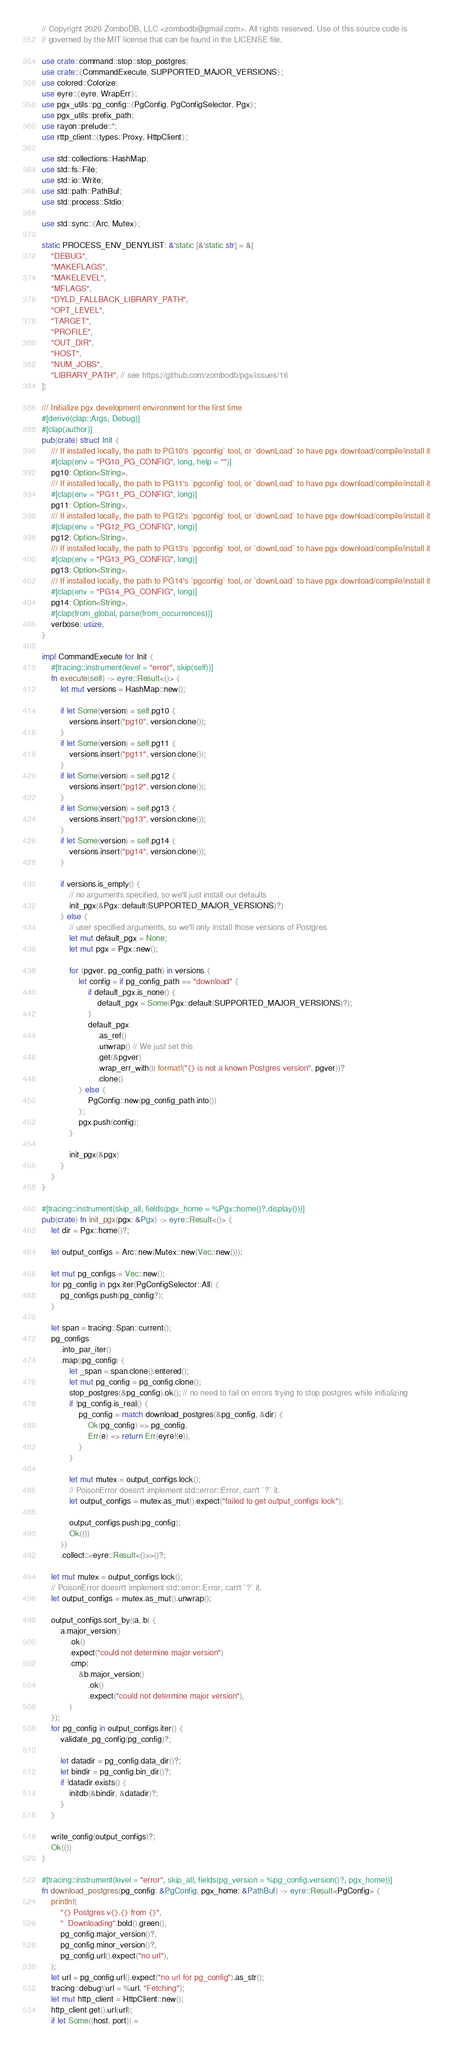Convert code to text. <code><loc_0><loc_0><loc_500><loc_500><_Rust_>// Copyright 2020 ZomboDB, LLC <zombodb@gmail.com>. All rights reserved. Use of this source code is
// governed by the MIT license that can be found in the LICENSE file.

use crate::command::stop::stop_postgres;
use crate::{CommandExecute, SUPPORTED_MAJOR_VERSIONS};
use colored::Colorize;
use eyre::{eyre, WrapErr};
use pgx_utils::pg_config::{PgConfig, PgConfigSelector, Pgx};
use pgx_utils::prefix_path;
use rayon::prelude::*;
use rttp_client::{types::Proxy, HttpClient};

use std::collections::HashMap;
use std::fs::File;
use std::io::Write;
use std::path::PathBuf;
use std::process::Stdio;

use std::sync::{Arc, Mutex};

static PROCESS_ENV_DENYLIST: &'static [&'static str] = &[
    "DEBUG",
    "MAKEFLAGS",
    "MAKELEVEL",
    "MFLAGS",
    "DYLD_FALLBACK_LIBRARY_PATH",
    "OPT_LEVEL",
    "TARGET",
    "PROFILE",
    "OUT_DIR",
    "HOST",
    "NUM_JOBS",
    "LIBRARY_PATH", // see https://github.com/zombodb/pgx/issues/16
];

/// Initialize pgx development environment for the first time
#[derive(clap::Args, Debug)]
#[clap(author)]
pub(crate) struct Init {
    /// If installed locally, the path to PG10's `pgconfig` tool, or `downLoad` to have pgx download/compile/install it
    #[clap(env = "PG10_PG_CONFIG", long, help = "")]
    pg10: Option<String>,
    /// If installed locally, the path to PG11's `pgconfig` tool, or `downLoad` to have pgx download/compile/install it
    #[clap(env = "PG11_PG_CONFIG", long)]
    pg11: Option<String>,
    /// If installed locally, the path to PG12's `pgconfig` tool, or `downLoad` to have pgx download/compile/install it
    #[clap(env = "PG12_PG_CONFIG", long)]
    pg12: Option<String>,
    /// If installed locally, the path to PG13's `pgconfig` tool, or `downLoad` to have pgx download/compile/install it
    #[clap(env = "PG13_PG_CONFIG", long)]
    pg13: Option<String>,
    /// If installed locally, the path to PG14's `pgconfig` tool, or `downLoad` to have pgx download/compile/install it
    #[clap(env = "PG14_PG_CONFIG", long)]
    pg14: Option<String>,
    #[clap(from_global, parse(from_occurrences))]
    verbose: usize,
}

impl CommandExecute for Init {
    #[tracing::instrument(level = "error", skip(self))]
    fn execute(self) -> eyre::Result<()> {
        let mut versions = HashMap::new();

        if let Some(version) = self.pg10 {
            versions.insert("pg10", version.clone());
        }
        if let Some(version) = self.pg11 {
            versions.insert("pg11", version.clone());
        }
        if let Some(version) = self.pg12 {
            versions.insert("pg12", version.clone());
        }
        if let Some(version) = self.pg13 {
            versions.insert("pg13", version.clone());
        }
        if let Some(version) = self.pg14 {
            versions.insert("pg14", version.clone());
        }

        if versions.is_empty() {
            // no arguments specified, so we'll just install our defaults
            init_pgx(&Pgx::default(SUPPORTED_MAJOR_VERSIONS)?)
        } else {
            // user specified arguments, so we'll only install those versions of Postgres
            let mut default_pgx = None;
            let mut pgx = Pgx::new();

            for (pgver, pg_config_path) in versions {
                let config = if pg_config_path == "download" {
                    if default_pgx.is_none() {
                        default_pgx = Some(Pgx::default(SUPPORTED_MAJOR_VERSIONS)?);
                    }
                    default_pgx
                        .as_ref()
                        .unwrap() // We just set this
                        .get(&pgver)
                        .wrap_err_with(|| format!("{} is not a known Postgres version", pgver))?
                        .clone()
                } else {
                    PgConfig::new(pg_config_path.into())
                };
                pgx.push(config);
            }

            init_pgx(&pgx)
        }
    }
}

#[tracing::instrument(skip_all, fields(pgx_home = %Pgx::home()?.display()))]
pub(crate) fn init_pgx(pgx: &Pgx) -> eyre::Result<()> {
    let dir = Pgx::home()?;

    let output_configs = Arc::new(Mutex::new(Vec::new()));

    let mut pg_configs = Vec::new();
    for pg_config in pgx.iter(PgConfigSelector::All) {
        pg_configs.push(pg_config?);
    }

    let span = tracing::Span::current();
    pg_configs
        .into_par_iter()
        .map(|pg_config| {
            let _span = span.clone().entered();
            let mut pg_config = pg_config.clone();
            stop_postgres(&pg_config).ok(); // no need to fail on errors trying to stop postgres while initializing
            if !pg_config.is_real() {
                pg_config = match download_postgres(&pg_config, &dir) {
                    Ok(pg_config) => pg_config,
                    Err(e) => return Err(eyre!(e)),
                }
            }

            let mut mutex = output_configs.lock();
            // PoisonError doesn't implement std::error::Error, can't `?` it.
            let output_configs = mutex.as_mut().expect("failed to get output_configs lock");

            output_configs.push(pg_config);
            Ok(())
        })
        .collect::<eyre::Result<()>>()?;

    let mut mutex = output_configs.lock();
    // PoisonError doesn't implement std::error::Error, can't `?` it.
    let output_configs = mutex.as_mut().unwrap();

    output_configs.sort_by(|a, b| {
        a.major_version()
            .ok()
            .expect("could not determine major version")
            .cmp(
                &b.major_version()
                    .ok()
                    .expect("could not determine major version"),
            )
    });
    for pg_config in output_configs.iter() {
        validate_pg_config(pg_config)?;

        let datadir = pg_config.data_dir()?;
        let bindir = pg_config.bin_dir()?;
        if !datadir.exists() {
            initdb(&bindir, &datadir)?;
        }
    }

    write_config(output_configs)?;
    Ok(())
}

#[tracing::instrument(level = "error", skip_all, fields(pg_version = %pg_config.version()?, pgx_home))]
fn download_postgres(pg_config: &PgConfig, pgx_home: &PathBuf) -> eyre::Result<PgConfig> {
    println!(
        "{} Postgres v{}.{} from {}",
        "  Downloading".bold().green(),
        pg_config.major_version()?,
        pg_config.minor_version()?,
        pg_config.url().expect("no url"),
    );
    let url = pg_config.url().expect("no url for pg_config").as_str();
    tracing::debug!(url = %url, "Fetching");
    let mut http_client = HttpClient::new();
    http_client.get().url(url);
    if let Some((host, port)) =</code> 